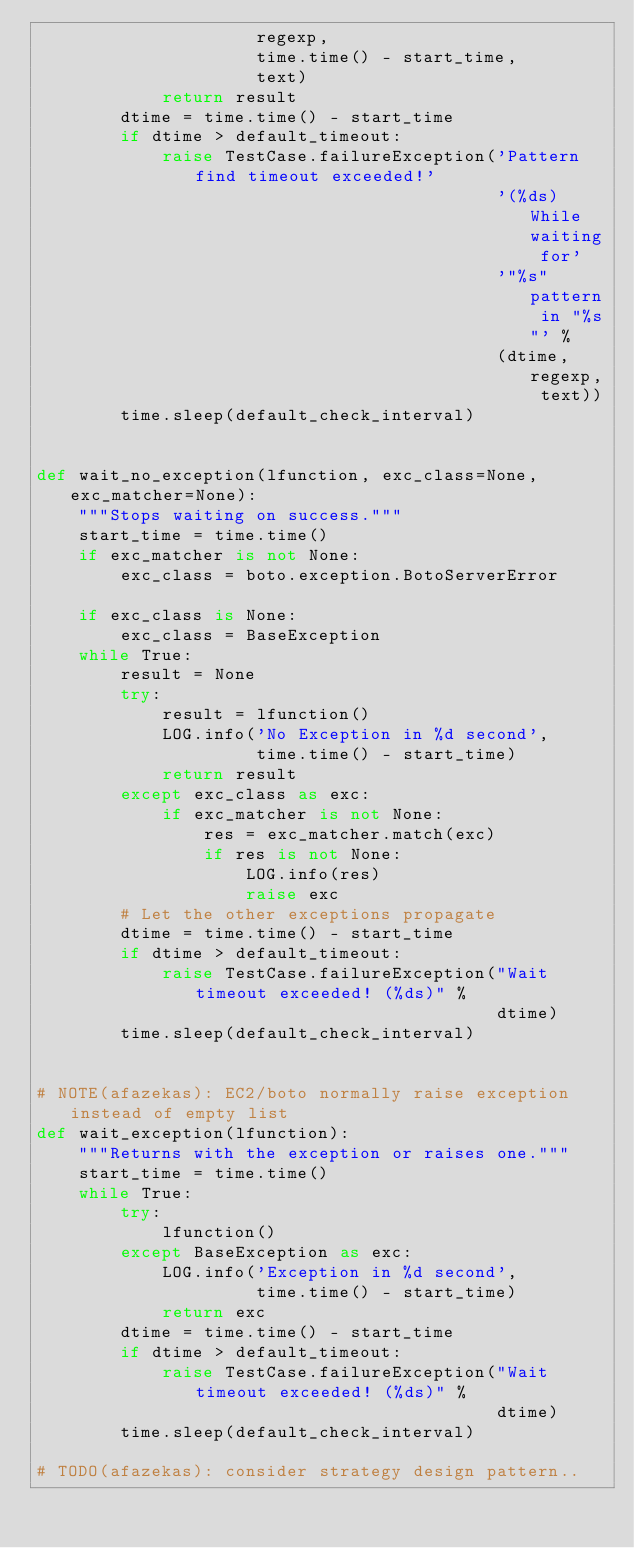Convert code to text. <code><loc_0><loc_0><loc_500><loc_500><_Python_>                     regexp,
                     time.time() - start_time,
                     text)
            return result
        dtime = time.time() - start_time
        if dtime > default_timeout:
            raise TestCase.failureException('Pattern find timeout exceeded!'
                                            '(%ds) While waiting for'
                                            '"%s" pattern in "%s"' %
                                            (dtime, regexp, text))
        time.sleep(default_check_interval)


def wait_no_exception(lfunction, exc_class=None, exc_matcher=None):
    """Stops waiting on success."""
    start_time = time.time()
    if exc_matcher is not None:
        exc_class = boto.exception.BotoServerError

    if exc_class is None:
        exc_class = BaseException
    while True:
        result = None
        try:
            result = lfunction()
            LOG.info('No Exception in %d second',
                     time.time() - start_time)
            return result
        except exc_class as exc:
            if exc_matcher is not None:
                res = exc_matcher.match(exc)
                if res is not None:
                    LOG.info(res)
                    raise exc
        # Let the other exceptions propagate
        dtime = time.time() - start_time
        if dtime > default_timeout:
            raise TestCase.failureException("Wait timeout exceeded! (%ds)" %
                                            dtime)
        time.sleep(default_check_interval)


# NOTE(afazekas): EC2/boto normally raise exception instead of empty list
def wait_exception(lfunction):
    """Returns with the exception or raises one."""
    start_time = time.time()
    while True:
        try:
            lfunction()
        except BaseException as exc:
            LOG.info('Exception in %d second',
                     time.time() - start_time)
            return exc
        dtime = time.time() - start_time
        if dtime > default_timeout:
            raise TestCase.failureException("Wait timeout exceeded! (%ds)" %
                                            dtime)
        time.sleep(default_check_interval)

# TODO(afazekas): consider strategy design pattern..
</code> 